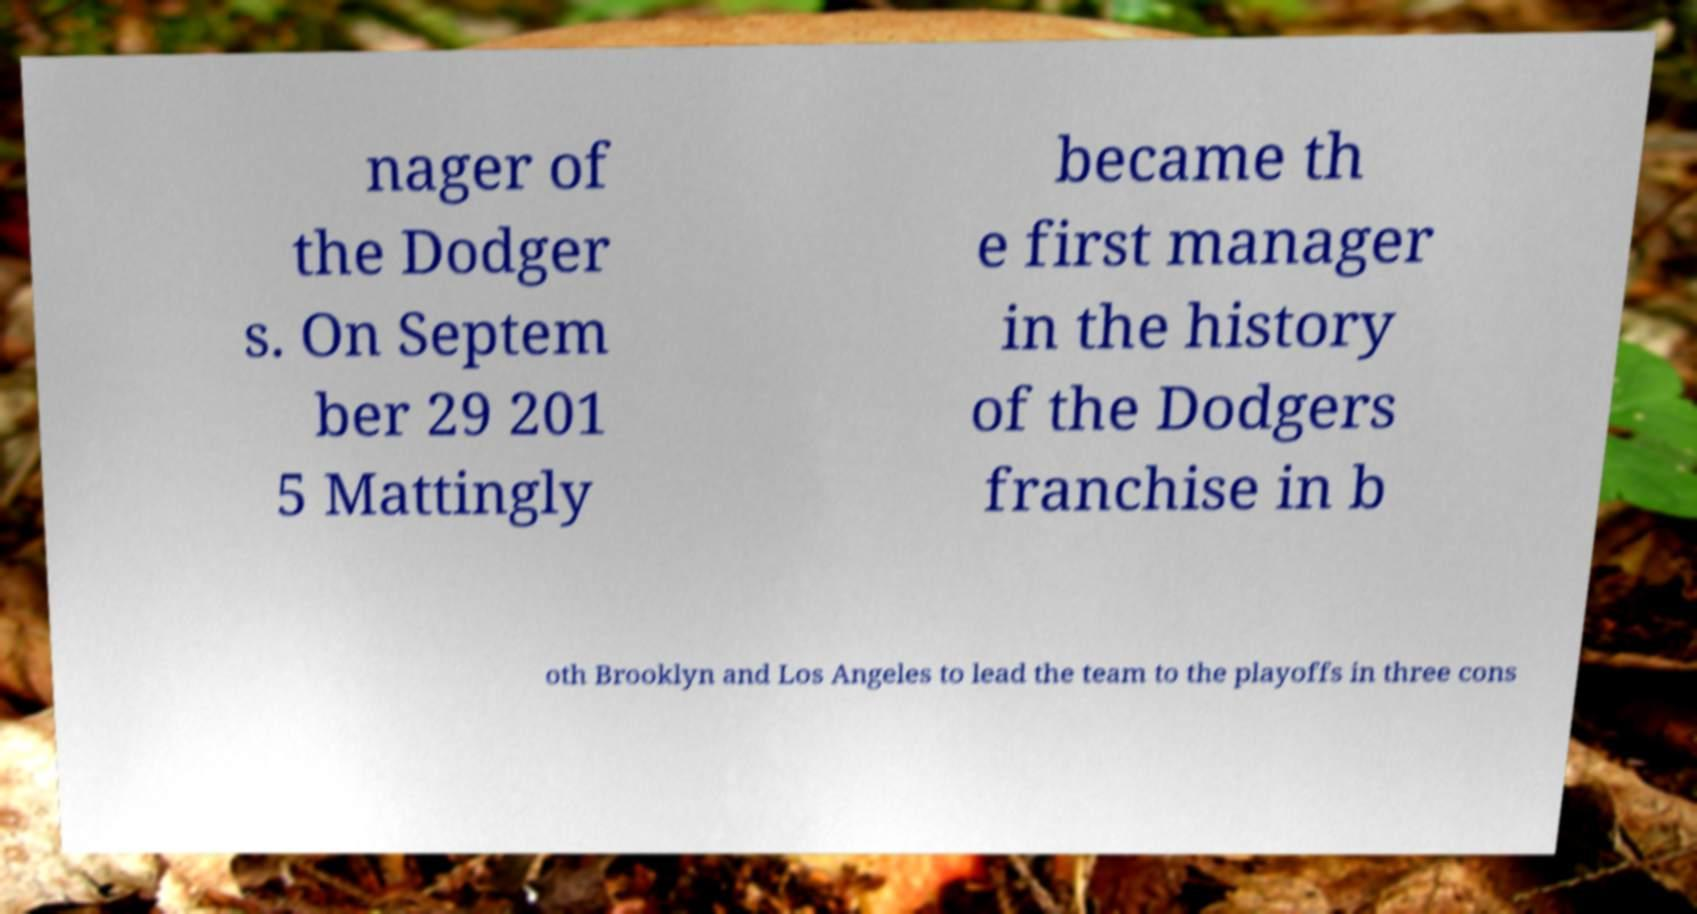Could you extract and type out the text from this image? nager of the Dodger s. On Septem ber 29 201 5 Mattingly became th e first manager in the history of the Dodgers franchise in b oth Brooklyn and Los Angeles to lead the team to the playoffs in three cons 